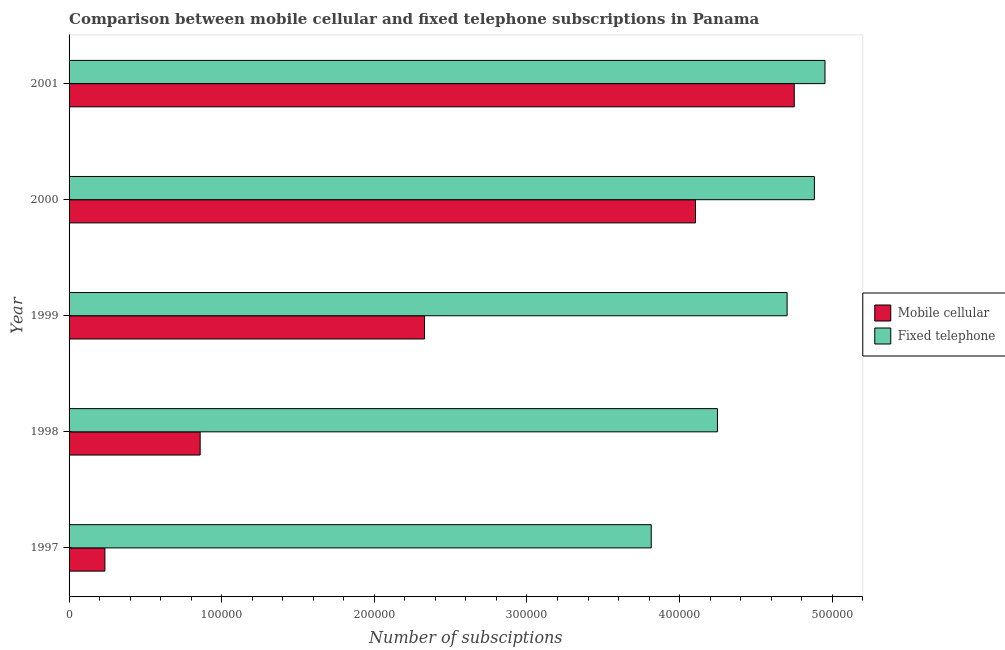Are the number of bars per tick equal to the number of legend labels?
Make the answer very short. Yes. In how many cases, is the number of bars for a given year not equal to the number of legend labels?
Your answer should be very brief. 0. What is the number of fixed telephone subscriptions in 2001?
Your answer should be compact. 4.95e+05. Across all years, what is the maximum number of mobile cellular subscriptions?
Your answer should be very brief. 4.75e+05. Across all years, what is the minimum number of mobile cellular subscriptions?
Your response must be concise. 2.35e+04. In which year was the number of fixed telephone subscriptions maximum?
Give a very brief answer. 2001. In which year was the number of mobile cellular subscriptions minimum?
Keep it short and to the point. 1997. What is the total number of fixed telephone subscriptions in the graph?
Make the answer very short. 2.26e+06. What is the difference between the number of mobile cellular subscriptions in 1998 and that in 2000?
Keep it short and to the point. -3.25e+05. What is the difference between the number of mobile cellular subscriptions in 1999 and the number of fixed telephone subscriptions in 2000?
Keep it short and to the point. -2.55e+05. What is the average number of mobile cellular subscriptions per year?
Offer a very short reply. 2.46e+05. In the year 1999, what is the difference between the number of fixed telephone subscriptions and number of mobile cellular subscriptions?
Offer a terse response. 2.38e+05. What is the ratio of the number of mobile cellular subscriptions in 1997 to that in 1998?
Make the answer very short. 0.27. Is the difference between the number of mobile cellular subscriptions in 1998 and 1999 greater than the difference between the number of fixed telephone subscriptions in 1998 and 1999?
Your answer should be very brief. No. What is the difference between the highest and the second highest number of fixed telephone subscriptions?
Provide a succinct answer. 6942. What is the difference between the highest and the lowest number of mobile cellular subscriptions?
Offer a very short reply. 4.52e+05. Is the sum of the number of fixed telephone subscriptions in 1998 and 2001 greater than the maximum number of mobile cellular subscriptions across all years?
Provide a short and direct response. Yes. What does the 1st bar from the top in 2000 represents?
Ensure brevity in your answer.  Fixed telephone. What does the 1st bar from the bottom in 1999 represents?
Make the answer very short. Mobile cellular. How many bars are there?
Your answer should be compact. 10. Are the values on the major ticks of X-axis written in scientific E-notation?
Your answer should be compact. No. Does the graph contain any zero values?
Keep it short and to the point. No. What is the title of the graph?
Ensure brevity in your answer.  Comparison between mobile cellular and fixed telephone subscriptions in Panama. Does "constant 2005 US$" appear as one of the legend labels in the graph?
Offer a terse response. No. What is the label or title of the X-axis?
Offer a very short reply. Number of subsciptions. What is the Number of subsciptions in Mobile cellular in 1997?
Provide a short and direct response. 2.35e+04. What is the Number of subsciptions of Fixed telephone in 1997?
Ensure brevity in your answer.  3.81e+05. What is the Number of subsciptions of Mobile cellular in 1998?
Ensure brevity in your answer.  8.59e+04. What is the Number of subsciptions in Fixed telephone in 1998?
Provide a short and direct response. 4.25e+05. What is the Number of subsciptions of Mobile cellular in 1999?
Give a very brief answer. 2.33e+05. What is the Number of subsciptions in Fixed telephone in 1999?
Offer a terse response. 4.70e+05. What is the Number of subsciptions in Mobile cellular in 2000?
Ensure brevity in your answer.  4.10e+05. What is the Number of subsciptions of Fixed telephone in 2000?
Offer a very short reply. 4.88e+05. What is the Number of subsciptions in Mobile cellular in 2001?
Keep it short and to the point. 4.75e+05. What is the Number of subsciptions of Fixed telephone in 2001?
Make the answer very short. 4.95e+05. Across all years, what is the maximum Number of subsciptions in Mobile cellular?
Ensure brevity in your answer.  4.75e+05. Across all years, what is the maximum Number of subsciptions of Fixed telephone?
Offer a very short reply. 4.95e+05. Across all years, what is the minimum Number of subsciptions in Mobile cellular?
Provide a succinct answer. 2.35e+04. Across all years, what is the minimum Number of subsciptions of Fixed telephone?
Your answer should be compact. 3.81e+05. What is the total Number of subsciptions of Mobile cellular in the graph?
Make the answer very short. 1.23e+06. What is the total Number of subsciptions of Fixed telephone in the graph?
Your answer should be very brief. 2.26e+06. What is the difference between the Number of subsciptions of Mobile cellular in 1997 and that in 1998?
Your answer should be very brief. -6.24e+04. What is the difference between the Number of subsciptions of Fixed telephone in 1997 and that in 1998?
Offer a terse response. -4.34e+04. What is the difference between the Number of subsciptions in Mobile cellular in 1997 and that in 1999?
Your answer should be compact. -2.09e+05. What is the difference between the Number of subsciptions in Fixed telephone in 1997 and that in 1999?
Provide a succinct answer. -8.90e+04. What is the difference between the Number of subsciptions in Mobile cellular in 1997 and that in 2000?
Offer a terse response. -3.87e+05. What is the difference between the Number of subsciptions in Fixed telephone in 1997 and that in 2000?
Your response must be concise. -1.07e+05. What is the difference between the Number of subsciptions of Mobile cellular in 1997 and that in 2001?
Offer a terse response. -4.52e+05. What is the difference between the Number of subsciptions in Fixed telephone in 1997 and that in 2001?
Provide a succinct answer. -1.14e+05. What is the difference between the Number of subsciptions in Mobile cellular in 1998 and that in 1999?
Your answer should be very brief. -1.47e+05. What is the difference between the Number of subsciptions of Fixed telephone in 1998 and that in 1999?
Offer a terse response. -4.56e+04. What is the difference between the Number of subsciptions of Mobile cellular in 1998 and that in 2000?
Offer a very short reply. -3.25e+05. What is the difference between the Number of subsciptions in Fixed telephone in 1998 and that in 2000?
Offer a very short reply. -6.35e+04. What is the difference between the Number of subsciptions in Mobile cellular in 1998 and that in 2001?
Offer a terse response. -3.89e+05. What is the difference between the Number of subsciptions of Fixed telephone in 1998 and that in 2001?
Your answer should be compact. -7.04e+04. What is the difference between the Number of subsciptions in Mobile cellular in 1999 and that in 2000?
Offer a very short reply. -1.78e+05. What is the difference between the Number of subsciptions in Fixed telephone in 1999 and that in 2000?
Your response must be concise. -1.79e+04. What is the difference between the Number of subsciptions in Mobile cellular in 1999 and that in 2001?
Your response must be concise. -2.42e+05. What is the difference between the Number of subsciptions in Fixed telephone in 1999 and that in 2001?
Offer a terse response. -2.48e+04. What is the difference between the Number of subsciptions in Mobile cellular in 2000 and that in 2001?
Keep it short and to the point. -6.47e+04. What is the difference between the Number of subsciptions of Fixed telephone in 2000 and that in 2001?
Provide a short and direct response. -6942. What is the difference between the Number of subsciptions in Mobile cellular in 1997 and the Number of subsciptions in Fixed telephone in 1998?
Keep it short and to the point. -4.01e+05. What is the difference between the Number of subsciptions in Mobile cellular in 1997 and the Number of subsciptions in Fixed telephone in 1999?
Your answer should be very brief. -4.47e+05. What is the difference between the Number of subsciptions of Mobile cellular in 1997 and the Number of subsciptions of Fixed telephone in 2000?
Make the answer very short. -4.65e+05. What is the difference between the Number of subsciptions of Mobile cellular in 1997 and the Number of subsciptions of Fixed telephone in 2001?
Offer a terse response. -4.72e+05. What is the difference between the Number of subsciptions in Mobile cellular in 1998 and the Number of subsciptions in Fixed telephone in 1999?
Offer a terse response. -3.85e+05. What is the difference between the Number of subsciptions in Mobile cellular in 1998 and the Number of subsciptions in Fixed telephone in 2000?
Offer a very short reply. -4.02e+05. What is the difference between the Number of subsciptions of Mobile cellular in 1998 and the Number of subsciptions of Fixed telephone in 2001?
Provide a succinct answer. -4.09e+05. What is the difference between the Number of subsciptions in Mobile cellular in 1999 and the Number of subsciptions in Fixed telephone in 2000?
Provide a succinct answer. -2.55e+05. What is the difference between the Number of subsciptions of Mobile cellular in 1999 and the Number of subsciptions of Fixed telephone in 2001?
Ensure brevity in your answer.  -2.62e+05. What is the difference between the Number of subsciptions in Mobile cellular in 2000 and the Number of subsciptions in Fixed telephone in 2001?
Offer a very short reply. -8.48e+04. What is the average Number of subsciptions in Mobile cellular per year?
Make the answer very short. 2.46e+05. What is the average Number of subsciptions in Fixed telephone per year?
Offer a terse response. 4.52e+05. In the year 1997, what is the difference between the Number of subsciptions of Mobile cellular and Number of subsciptions of Fixed telephone?
Provide a short and direct response. -3.58e+05. In the year 1998, what is the difference between the Number of subsciptions of Mobile cellular and Number of subsciptions of Fixed telephone?
Offer a very short reply. -3.39e+05. In the year 1999, what is the difference between the Number of subsciptions in Mobile cellular and Number of subsciptions in Fixed telephone?
Give a very brief answer. -2.38e+05. In the year 2000, what is the difference between the Number of subsciptions of Mobile cellular and Number of subsciptions of Fixed telephone?
Provide a succinct answer. -7.79e+04. In the year 2001, what is the difference between the Number of subsciptions in Mobile cellular and Number of subsciptions in Fixed telephone?
Keep it short and to the point. -2.01e+04. What is the ratio of the Number of subsciptions in Mobile cellular in 1997 to that in 1998?
Offer a very short reply. 0.27. What is the ratio of the Number of subsciptions in Fixed telephone in 1997 to that in 1998?
Keep it short and to the point. 0.9. What is the ratio of the Number of subsciptions in Mobile cellular in 1997 to that in 1999?
Keep it short and to the point. 0.1. What is the ratio of the Number of subsciptions in Fixed telephone in 1997 to that in 1999?
Offer a terse response. 0.81. What is the ratio of the Number of subsciptions in Mobile cellular in 1997 to that in 2000?
Keep it short and to the point. 0.06. What is the ratio of the Number of subsciptions of Fixed telephone in 1997 to that in 2000?
Make the answer very short. 0.78. What is the ratio of the Number of subsciptions of Mobile cellular in 1997 to that in 2001?
Give a very brief answer. 0.05. What is the ratio of the Number of subsciptions in Fixed telephone in 1997 to that in 2001?
Offer a terse response. 0.77. What is the ratio of the Number of subsciptions of Mobile cellular in 1998 to that in 1999?
Ensure brevity in your answer.  0.37. What is the ratio of the Number of subsciptions in Fixed telephone in 1998 to that in 1999?
Offer a very short reply. 0.9. What is the ratio of the Number of subsciptions in Mobile cellular in 1998 to that in 2000?
Your answer should be very brief. 0.21. What is the ratio of the Number of subsciptions of Fixed telephone in 1998 to that in 2000?
Offer a very short reply. 0.87. What is the ratio of the Number of subsciptions of Mobile cellular in 1998 to that in 2001?
Your answer should be very brief. 0.18. What is the ratio of the Number of subsciptions of Fixed telephone in 1998 to that in 2001?
Keep it short and to the point. 0.86. What is the ratio of the Number of subsciptions of Mobile cellular in 1999 to that in 2000?
Your answer should be compact. 0.57. What is the ratio of the Number of subsciptions of Fixed telephone in 1999 to that in 2000?
Provide a short and direct response. 0.96. What is the ratio of the Number of subsciptions in Mobile cellular in 1999 to that in 2001?
Keep it short and to the point. 0.49. What is the ratio of the Number of subsciptions of Fixed telephone in 1999 to that in 2001?
Provide a succinct answer. 0.95. What is the ratio of the Number of subsciptions of Mobile cellular in 2000 to that in 2001?
Give a very brief answer. 0.86. What is the difference between the highest and the second highest Number of subsciptions in Mobile cellular?
Provide a succinct answer. 6.47e+04. What is the difference between the highest and the second highest Number of subsciptions in Fixed telephone?
Your response must be concise. 6942. What is the difference between the highest and the lowest Number of subsciptions in Mobile cellular?
Offer a terse response. 4.52e+05. What is the difference between the highest and the lowest Number of subsciptions of Fixed telephone?
Provide a succinct answer. 1.14e+05. 